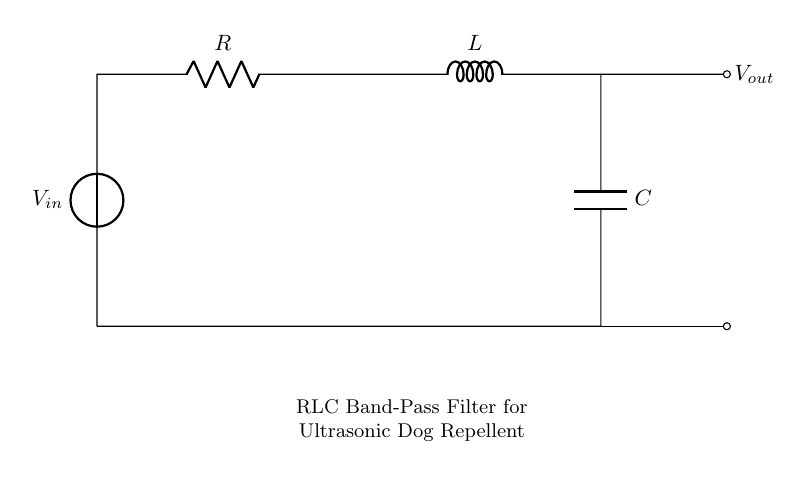What is the input voltage source labeled in the circuit? The circuit shows the voltage source labeled as \( V_{in} \) connected at the leftmost side. This indicates the point where electricity enters the circuit.
Answer: V in Which component is connected in series with the resistor? The circuit diagram shows that the inductor is directly connected in series to the resistor, following the path from left to right. This indicates they are part of the same branch in the circuit.
Answer: L What type of filter is represented by this circuit? The circuit is specifically designed as a band-pass filter, which allows certain frequencies to pass while attenuating others, useful for the ultrasonic frequencies.
Answer: Band-pass filter What components are used in this RLC topology? The circuit consists of three components: a resistor, an inductor, and a capacitor. These elements together form the RLC circuit essential for the filtering behavior.
Answer: Resistor, Inductor, Capacitor How does the capacitor interact with the inductor at high frequencies? At high frequencies, the inductor tends to block the current flow, while the capacitor acts to bypass high-frequency signals to ground, creating a specific frequency response characteristic of a band-pass filter.
Answer: Blocks current What is the purpose of this circuit in the context of a dog repellent device? The RLC band-pass filter is utilized in the device to generate ultrasonic sound waves at a certain frequency range, which is effective for repelling dogs.
Answer: Generate ultrasonic waves 